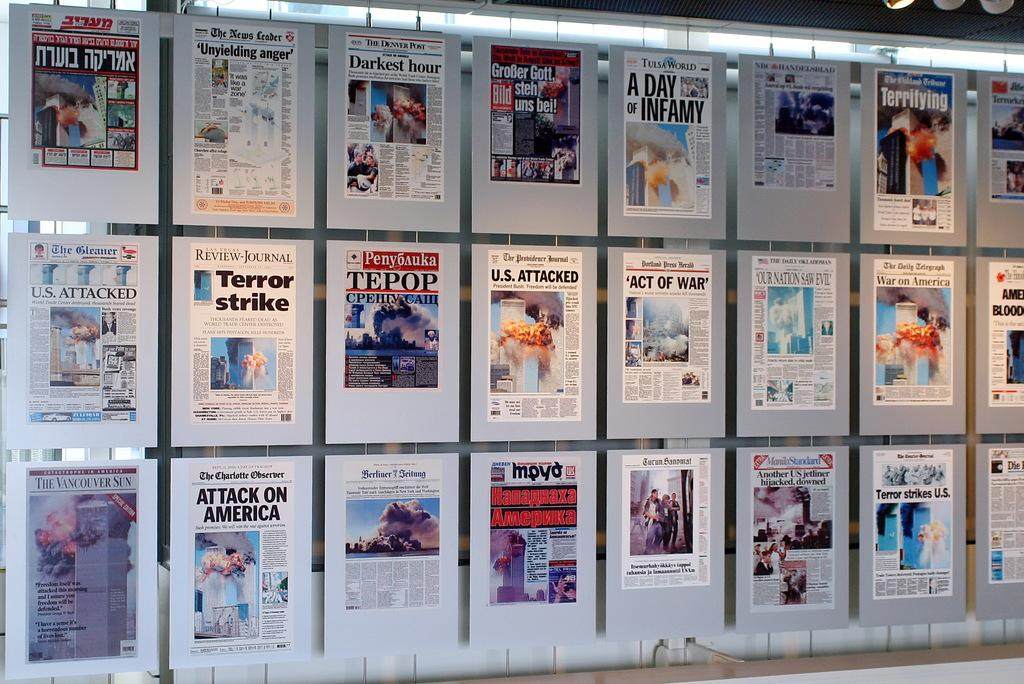<image>
Present a compact description of the photo's key features. front page newspaper displays on wall from The News Leader, The Denver Post, Tulsa World, Las Vegas Review-Journal, The Providence Journal, The 